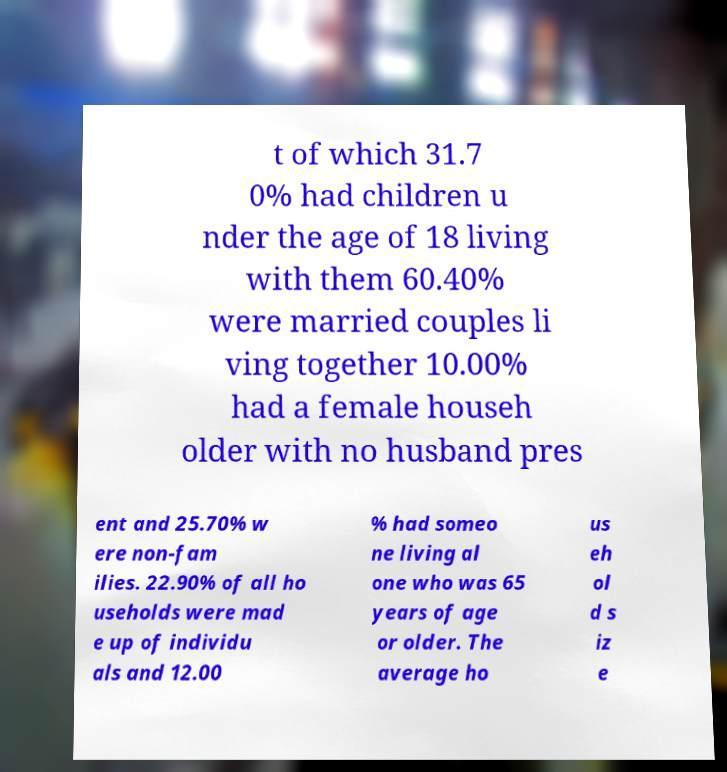What messages or text are displayed in this image? I need them in a readable, typed format. t of which 31.7 0% had children u nder the age of 18 living with them 60.40% were married couples li ving together 10.00% had a female househ older with no husband pres ent and 25.70% w ere non-fam ilies. 22.90% of all ho useholds were mad e up of individu als and 12.00 % had someo ne living al one who was 65 years of age or older. The average ho us eh ol d s iz e 